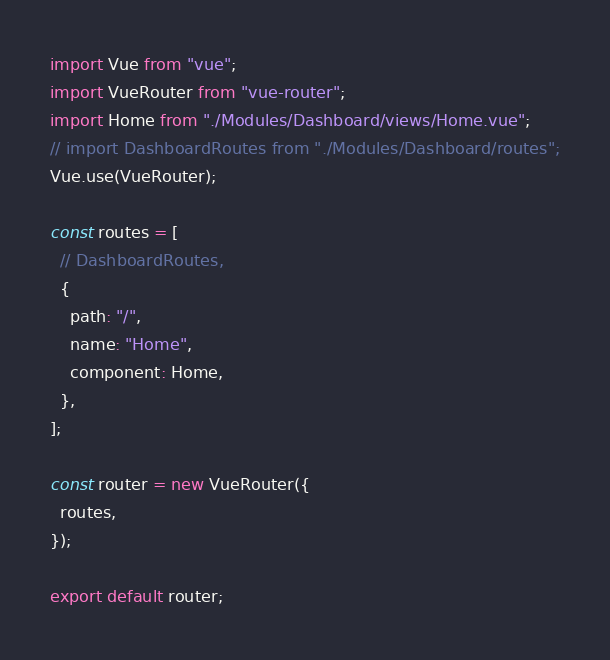<code> <loc_0><loc_0><loc_500><loc_500><_JavaScript_>import Vue from "vue";
import VueRouter from "vue-router";
import Home from "./Modules/Dashboard/views/Home.vue";
// import DashboardRoutes from "./Modules/Dashboard/routes";
Vue.use(VueRouter);

const routes = [
  // DashboardRoutes,
  {
    path: "/",
    name: "Home",
    component: Home,
  },
];

const router = new VueRouter({
  routes,
});

export default router;
</code> 